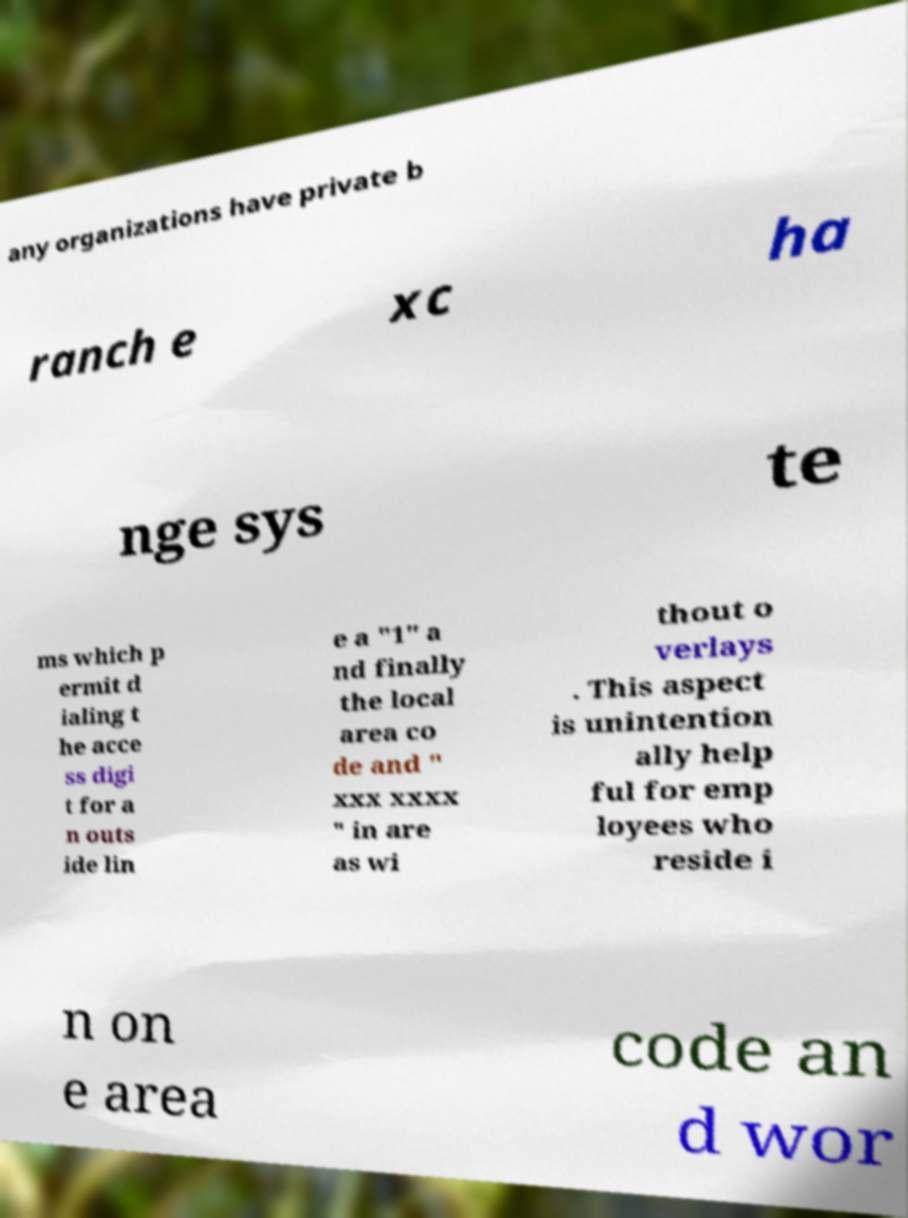Can you accurately transcribe the text from the provided image for me? any organizations have private b ranch e xc ha nge sys te ms which p ermit d ialing t he acce ss digi t for a n outs ide lin e a "1" a nd finally the local area co de and " xxx xxxx " in are as wi thout o verlays . This aspect is unintention ally help ful for emp loyees who reside i n on e area code an d wor 